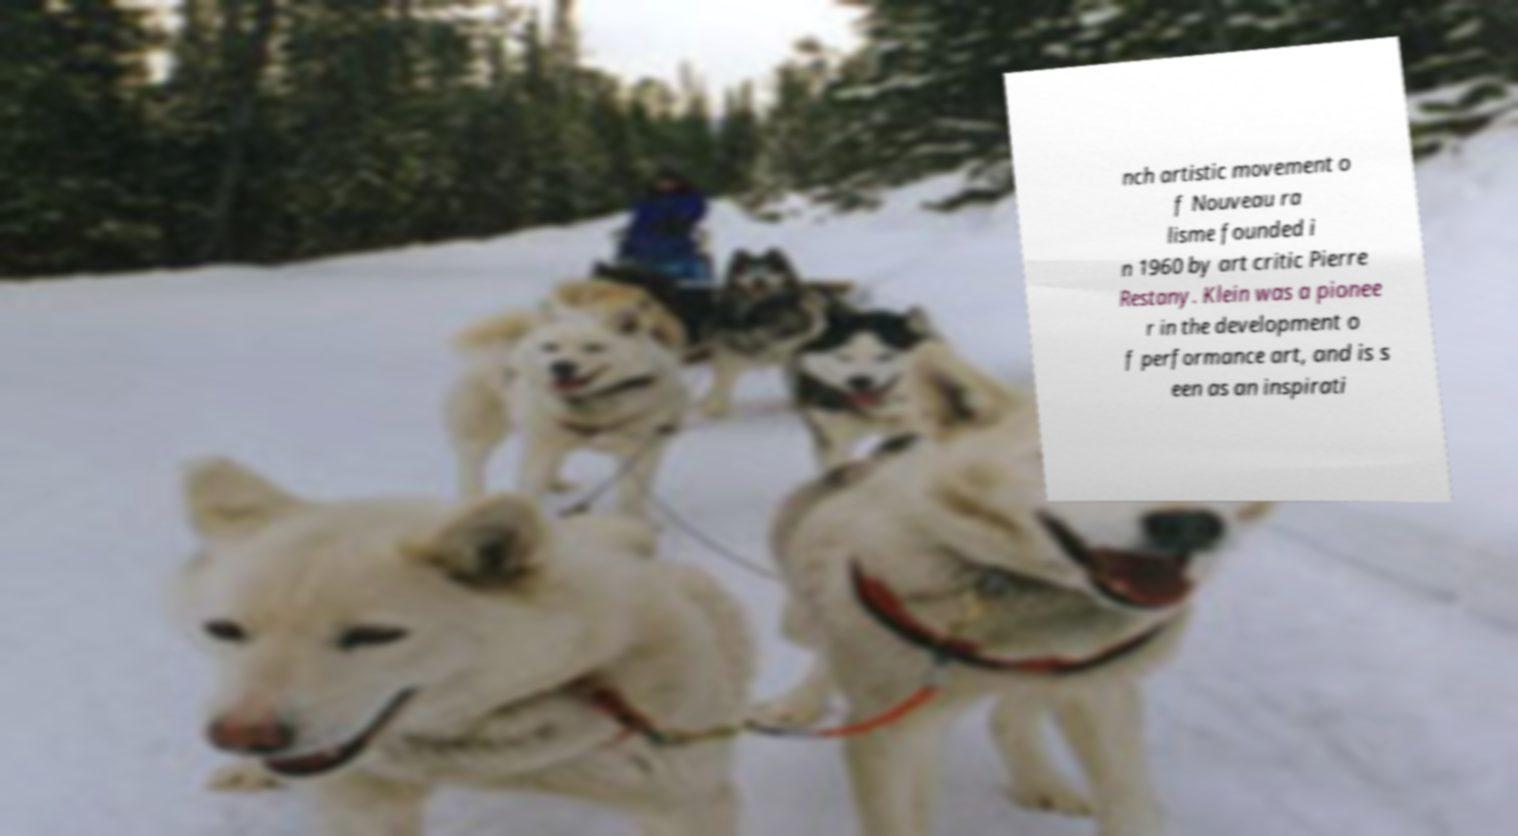Can you accurately transcribe the text from the provided image for me? nch artistic movement o f Nouveau ra lisme founded i n 1960 by art critic Pierre Restany. Klein was a pionee r in the development o f performance art, and is s een as an inspirati 